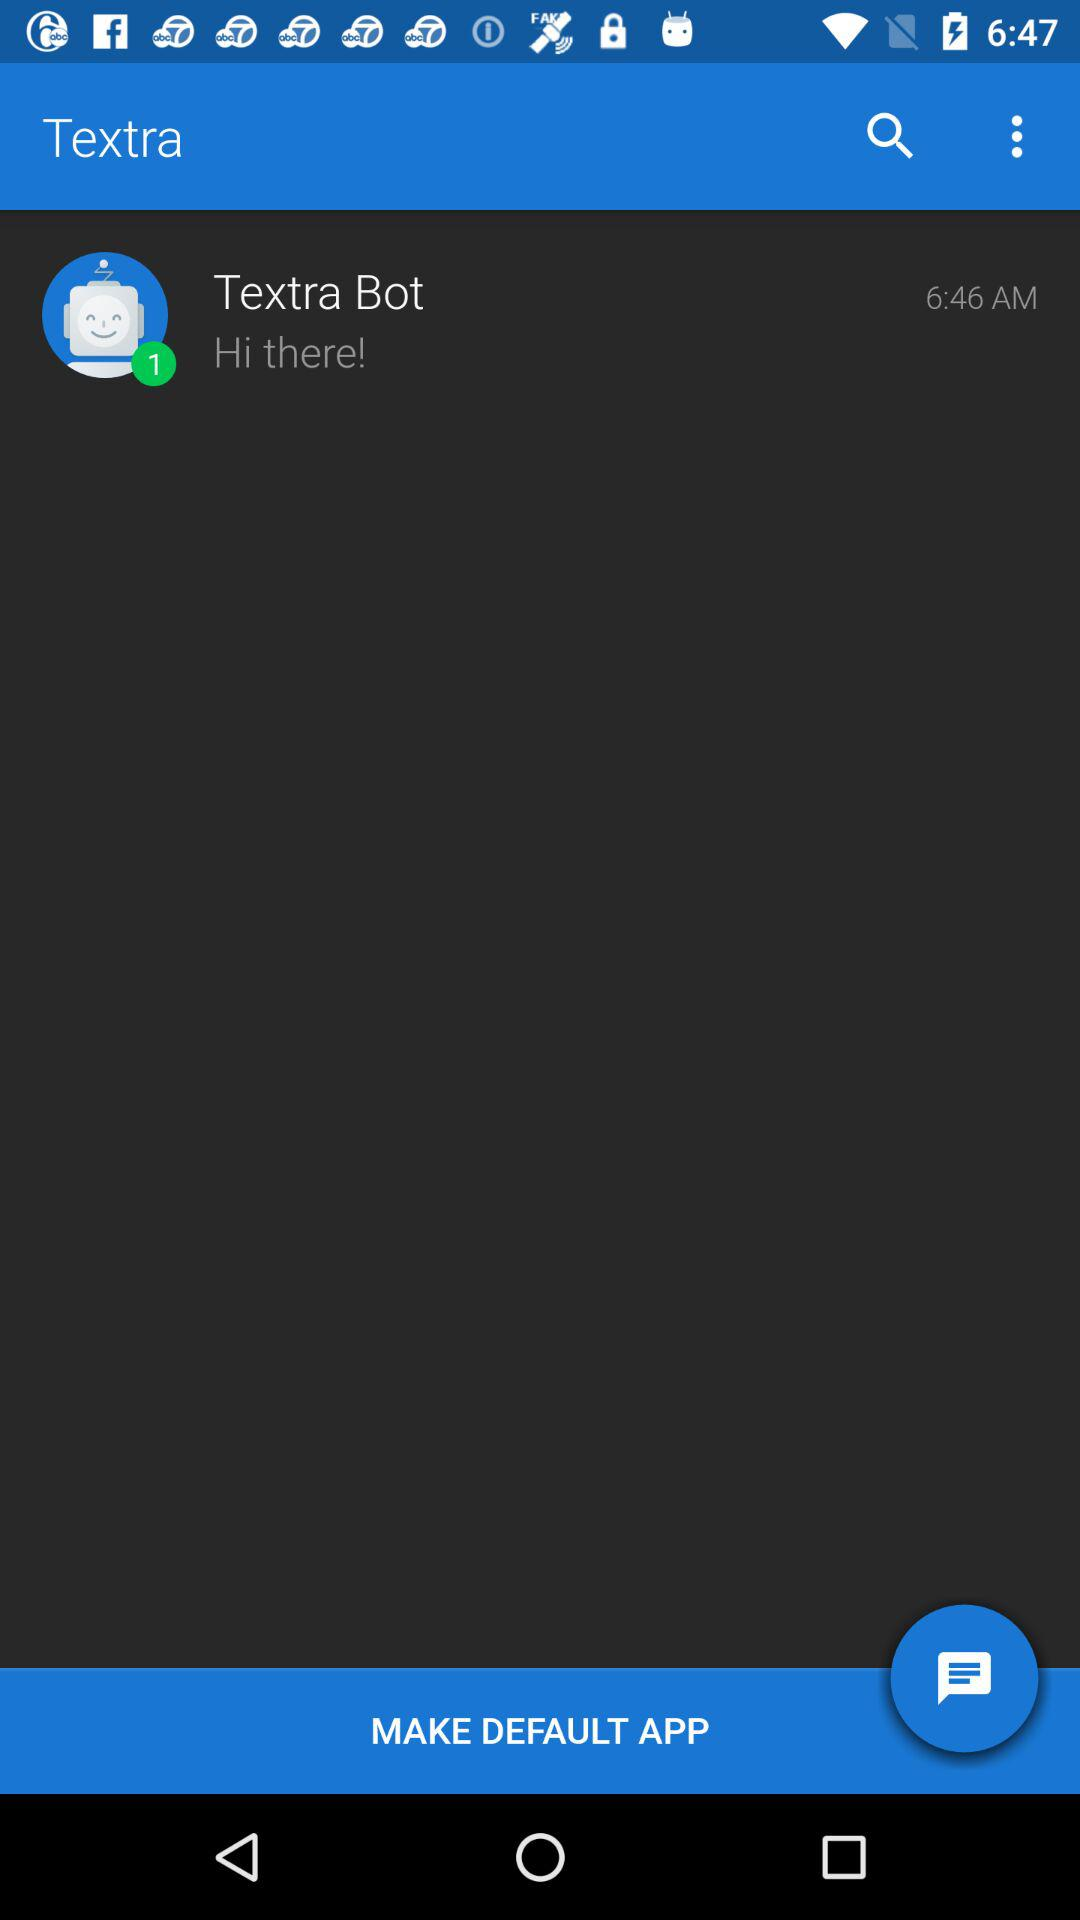How many new messages are there from the "Textra" bot? There is 1 new message from the "Textra" bot. 